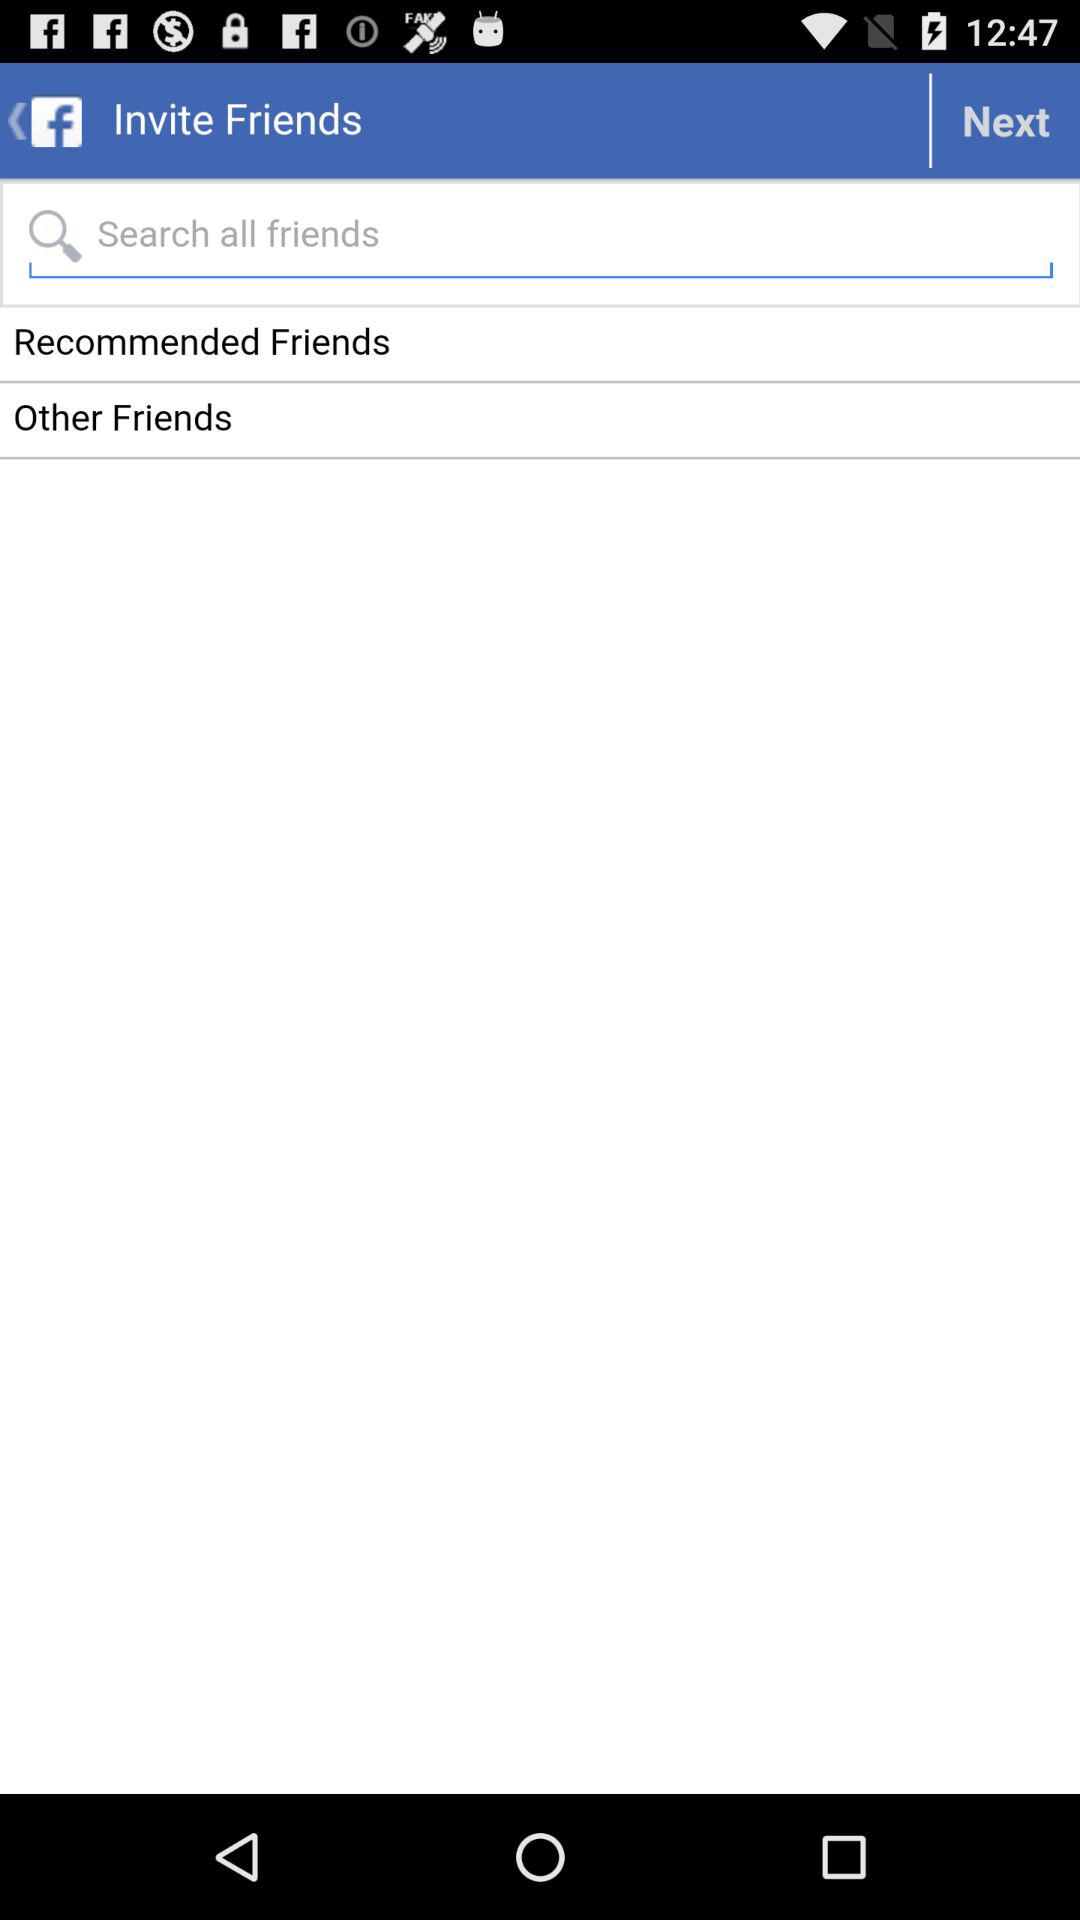What is the user name? The user name is Grace. 